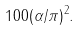<formula> <loc_0><loc_0><loc_500><loc_500>1 0 0 ( \alpha / \pi ) ^ { 2 } .</formula> 